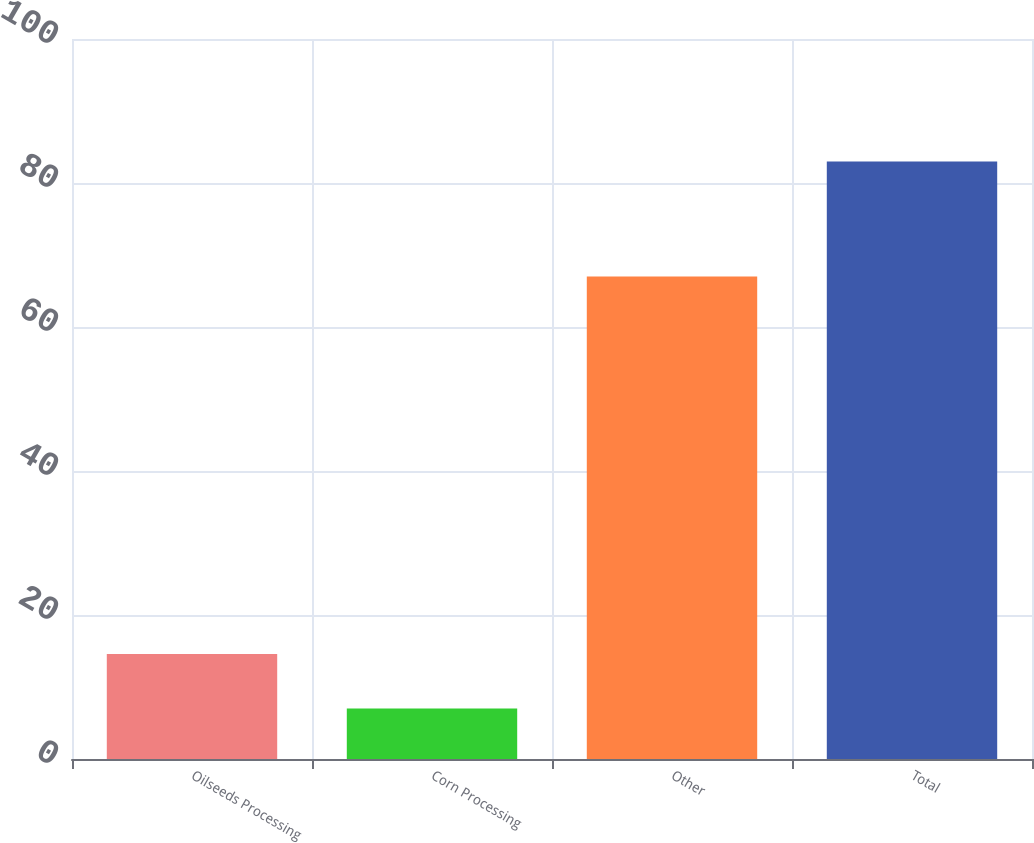Convert chart. <chart><loc_0><loc_0><loc_500><loc_500><bar_chart><fcel>Oilseeds Processing<fcel>Corn Processing<fcel>Other<fcel>Total<nl><fcel>14.6<fcel>7<fcel>67<fcel>83<nl></chart> 